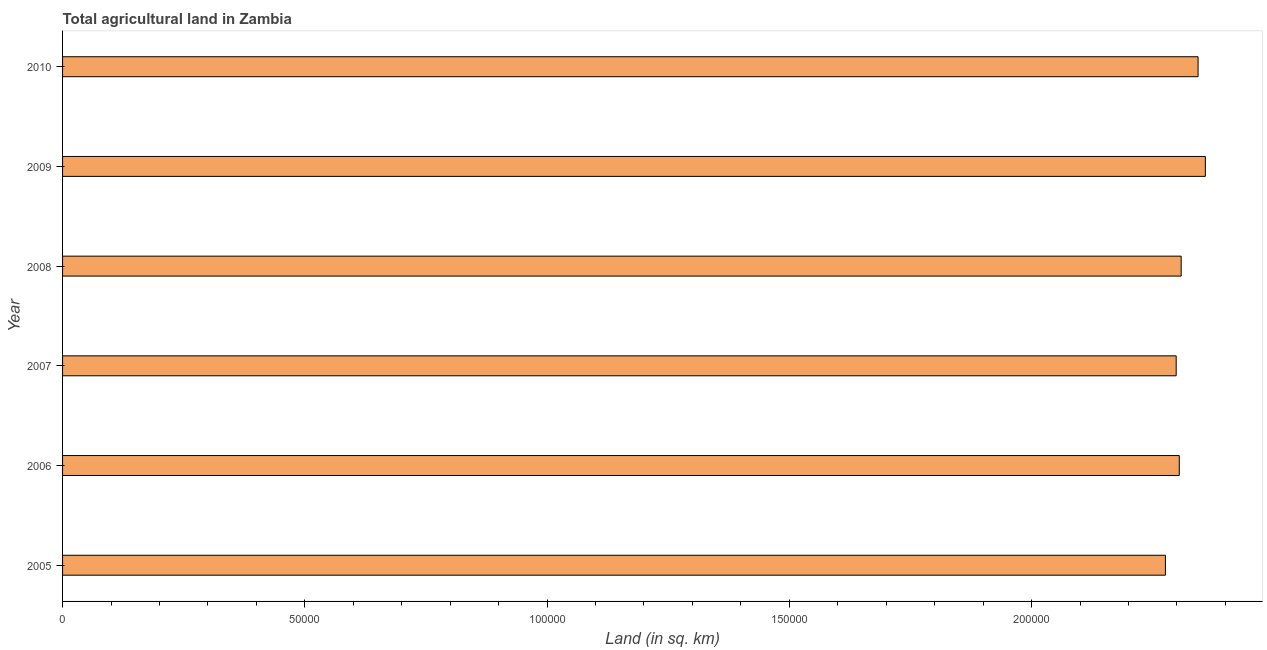Does the graph contain grids?
Your answer should be compact. No. What is the title of the graph?
Provide a succinct answer. Total agricultural land in Zambia. What is the label or title of the X-axis?
Provide a succinct answer. Land (in sq. km). What is the agricultural land in 2006?
Your response must be concise. 2.30e+05. Across all years, what is the maximum agricultural land?
Your response must be concise. 2.36e+05. Across all years, what is the minimum agricultural land?
Give a very brief answer. 2.28e+05. What is the sum of the agricultural land?
Give a very brief answer. 1.39e+06. What is the difference between the agricultural land in 2006 and 2010?
Keep it short and to the point. -3880. What is the average agricultural land per year?
Give a very brief answer. 2.32e+05. What is the median agricultural land?
Your answer should be very brief. 2.31e+05. In how many years, is the agricultural land greater than 90000 sq. km?
Your answer should be compact. 6. Do a majority of the years between 2009 and 2006 (inclusive) have agricultural land greater than 160000 sq. km?
Ensure brevity in your answer.  Yes. What is the ratio of the agricultural land in 2008 to that in 2010?
Keep it short and to the point. 0.98. Is the difference between the agricultural land in 2009 and 2010 greater than the difference between any two years?
Provide a short and direct response. No. What is the difference between the highest and the second highest agricultural land?
Offer a terse response. 1500. What is the difference between the highest and the lowest agricultural land?
Your response must be concise. 8240. In how many years, is the agricultural land greater than the average agricultural land taken over all years?
Give a very brief answer. 2. How many bars are there?
Your answer should be compact. 6. How many years are there in the graph?
Provide a short and direct response. 6. What is the Land (in sq. km) of 2005?
Provide a short and direct response. 2.28e+05. What is the Land (in sq. km) in 2006?
Your answer should be very brief. 2.30e+05. What is the Land (in sq. km) of 2007?
Give a very brief answer. 2.30e+05. What is the Land (in sq. km) of 2008?
Your answer should be compact. 2.31e+05. What is the Land (in sq. km) of 2009?
Ensure brevity in your answer.  2.36e+05. What is the Land (in sq. km) in 2010?
Keep it short and to the point. 2.34e+05. What is the difference between the Land (in sq. km) in 2005 and 2006?
Your response must be concise. -2860. What is the difference between the Land (in sq. km) in 2005 and 2007?
Your answer should be very brief. -2220. What is the difference between the Land (in sq. km) in 2005 and 2008?
Provide a short and direct response. -3250. What is the difference between the Land (in sq. km) in 2005 and 2009?
Keep it short and to the point. -8240. What is the difference between the Land (in sq. km) in 2005 and 2010?
Offer a terse response. -6740. What is the difference between the Land (in sq. km) in 2006 and 2007?
Your response must be concise. 640. What is the difference between the Land (in sq. km) in 2006 and 2008?
Offer a very short reply. -390. What is the difference between the Land (in sq. km) in 2006 and 2009?
Keep it short and to the point. -5380. What is the difference between the Land (in sq. km) in 2006 and 2010?
Make the answer very short. -3880. What is the difference between the Land (in sq. km) in 2007 and 2008?
Provide a succinct answer. -1030. What is the difference between the Land (in sq. km) in 2007 and 2009?
Ensure brevity in your answer.  -6020. What is the difference between the Land (in sq. km) in 2007 and 2010?
Provide a short and direct response. -4520. What is the difference between the Land (in sq. km) in 2008 and 2009?
Your answer should be compact. -4990. What is the difference between the Land (in sq. km) in 2008 and 2010?
Your response must be concise. -3490. What is the difference between the Land (in sq. km) in 2009 and 2010?
Provide a short and direct response. 1500. What is the ratio of the Land (in sq. km) in 2005 to that in 2006?
Make the answer very short. 0.99. What is the ratio of the Land (in sq. km) in 2005 to that in 2008?
Your answer should be compact. 0.99. What is the ratio of the Land (in sq. km) in 2006 to that in 2009?
Your answer should be very brief. 0.98. What is the ratio of the Land (in sq. km) in 2006 to that in 2010?
Provide a short and direct response. 0.98. What is the ratio of the Land (in sq. km) in 2007 to that in 2010?
Give a very brief answer. 0.98. What is the ratio of the Land (in sq. km) in 2008 to that in 2009?
Your response must be concise. 0.98. What is the ratio of the Land (in sq. km) in 2009 to that in 2010?
Keep it short and to the point. 1.01. 